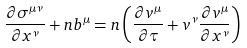<formula> <loc_0><loc_0><loc_500><loc_500>\frac { \partial \sigma ^ { \mu \nu } } { \partial x ^ { \nu } } + n b ^ { \mu } = n \left ( \frac { \partial v ^ { \mu } } { \partial \tau } + v ^ { \nu } \frac { \partial v ^ { \mu } } { \partial x ^ { \nu } } \right )</formula> 